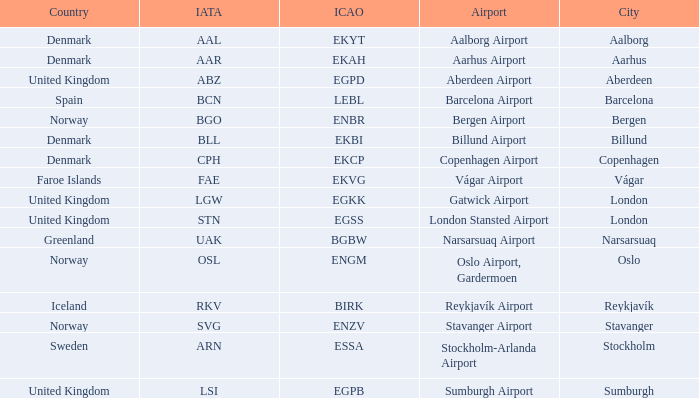What airport has an IATA of ARN? Stockholm-Arlanda Airport. 